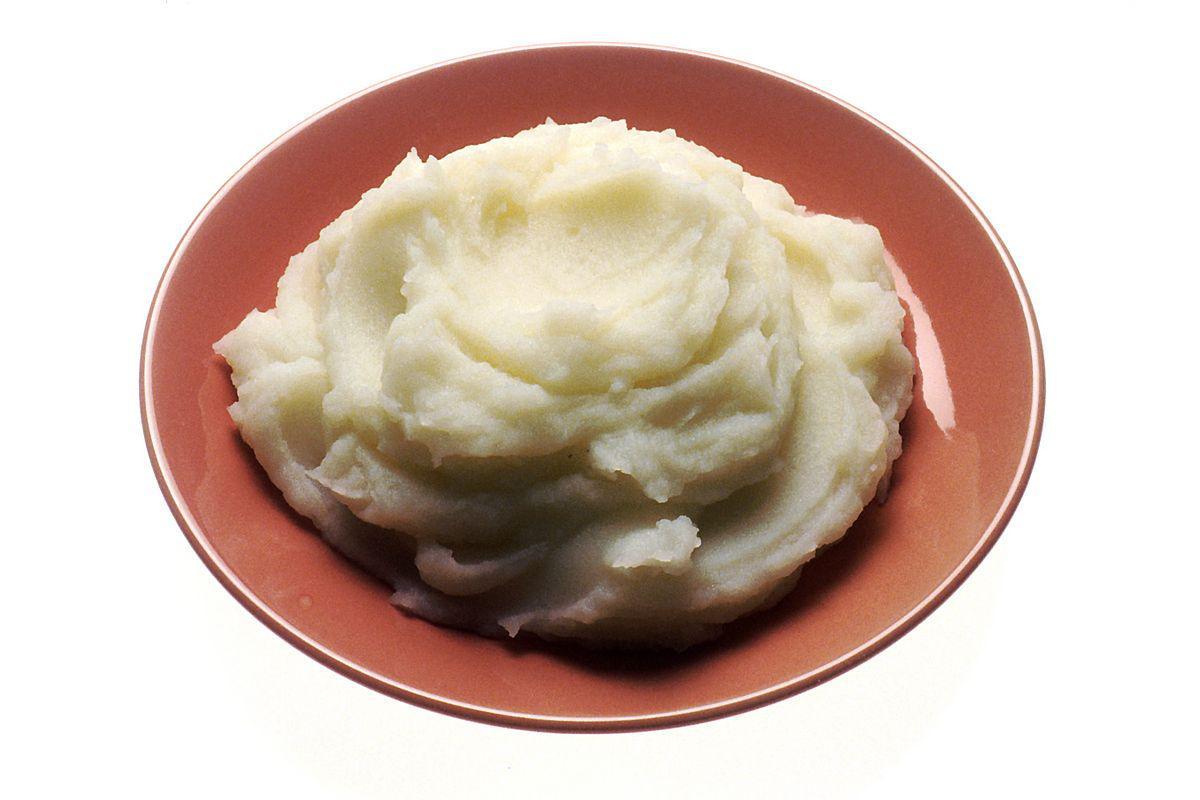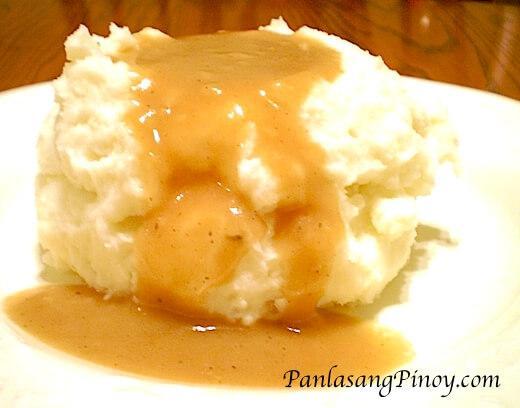The first image is the image on the left, the second image is the image on the right. Evaluate the accuracy of this statement regarding the images: "herbs are sprinkled over the mashed potato". Is it true? Answer yes or no. No. 